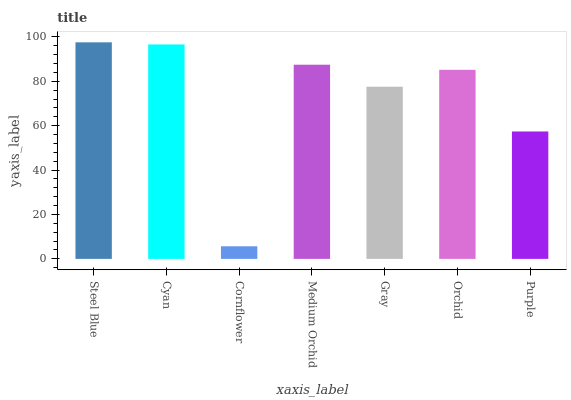Is Cornflower the minimum?
Answer yes or no. Yes. Is Steel Blue the maximum?
Answer yes or no. Yes. Is Cyan the minimum?
Answer yes or no. No. Is Cyan the maximum?
Answer yes or no. No. Is Steel Blue greater than Cyan?
Answer yes or no. Yes. Is Cyan less than Steel Blue?
Answer yes or no. Yes. Is Cyan greater than Steel Blue?
Answer yes or no. No. Is Steel Blue less than Cyan?
Answer yes or no. No. Is Orchid the high median?
Answer yes or no. Yes. Is Orchid the low median?
Answer yes or no. Yes. Is Cyan the high median?
Answer yes or no. No. Is Cornflower the low median?
Answer yes or no. No. 